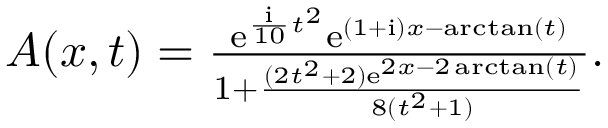Convert formula to latex. <formula><loc_0><loc_0><loc_500><loc_500>\begin{array} { r } { A ( x , t ) = \frac { e ^ { \frac { i } { 1 0 } t ^ { 2 } } e ^ { ( 1 + { i } ) x - \arctan ( t ) } } { 1 + \frac { ( 2 t ^ { 2 } + 2 ) e ^ { 2 x - 2 \arctan ( t ) } } { 8 ( t ^ { 2 } + 1 ) } } . } \end{array}</formula> 